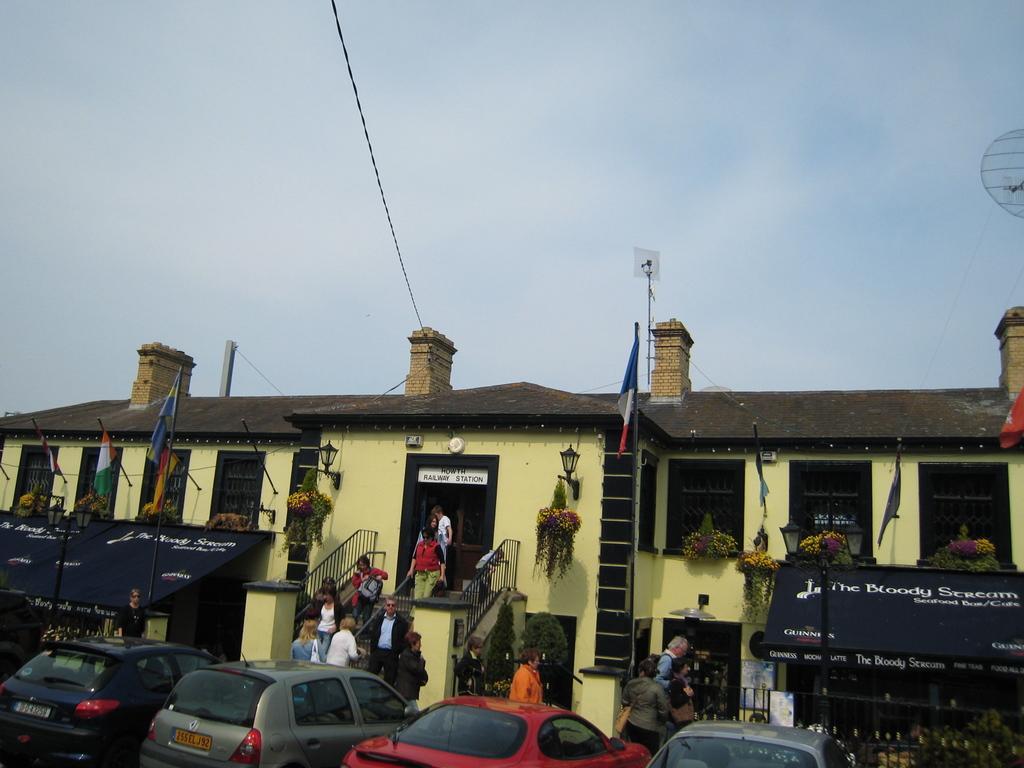In one or two sentences, can you explain what this image depicts? In the picture I can see these cars are parked here, we can see a few people walking on the road and a few people getting down the steps, we can see tents, light poles, flags, house, wires and the cloudy sky in the background. 